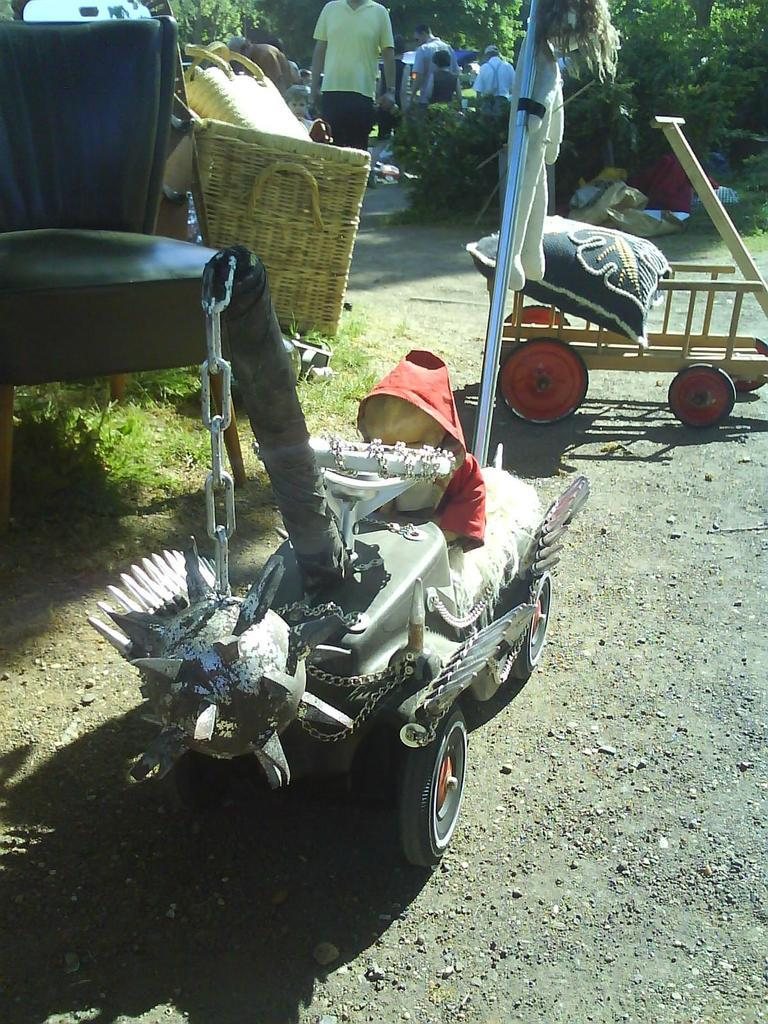What is the main subject in the image? There is a vehicle in the image. What is happening in the middle of the image? A person is walking in the middle of the image. What is the person wearing? The person is wearing a yellow t-shirt. What type of vegetation can be seen on the right side of the image? There are plants on the right side of the image. What type of pen is the person using to write on the vehicle in the image? There is no pen or writing present in the image; the person is simply walking. 